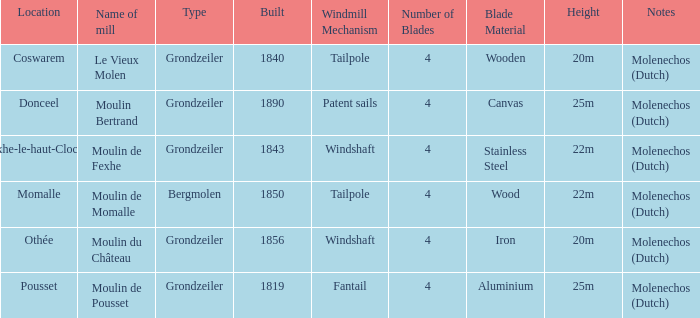What is the Location of the Moulin Bertrand Mill? Donceel. 